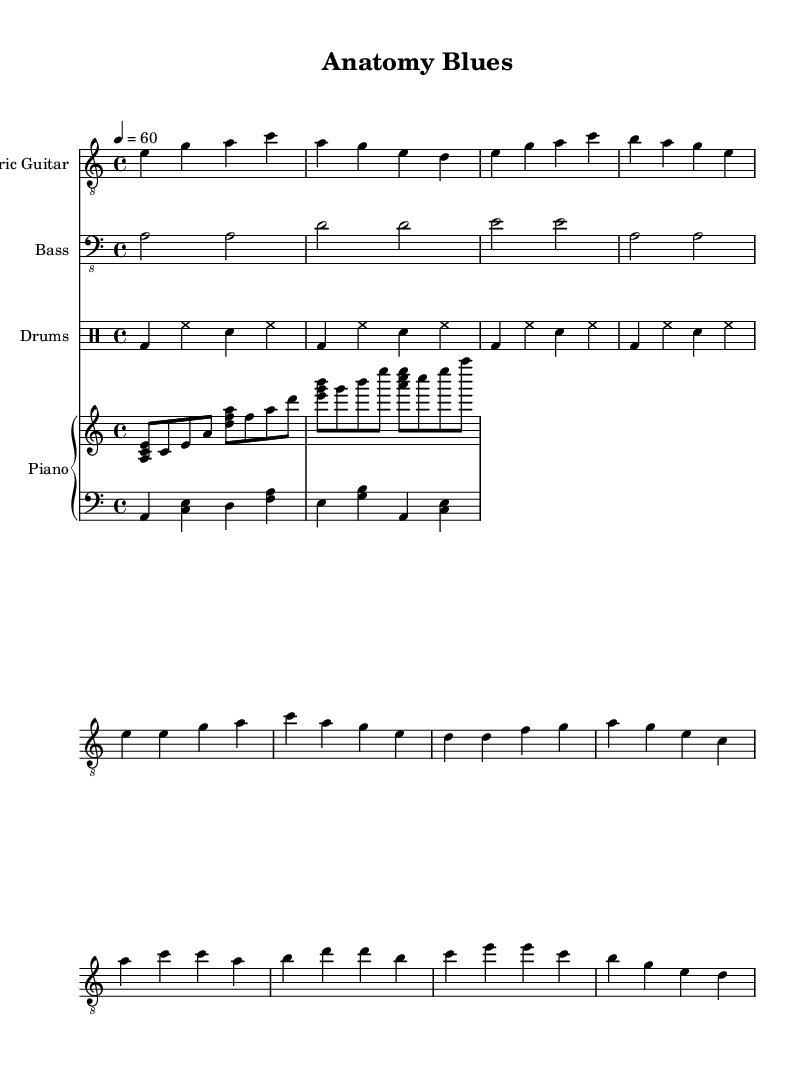What is the key signature of this music? The key signature shows an A minor key, indicated by zero sharps and flats in the context of the relative major, C major.
Answer: A minor What is the time signature of this music? The time signature is written at the beginning of the score as 4/4, meaning there are four beats per measure, and the quarter note gets one beat.
Answer: 4/4 What is the tempo marking of this music? The tempo marking is indicated as a quarter note equals 60 beats per minute, suggesting a slow to moderate pace for the piece.
Answer: 60 How many measures are there in the electric guitar part? Counting the segments separated by bar lines in the electric guitar staff shows there are a total of 12 measures.
Answer: 12 What kind of rhythm is predominantly used in the drum part? The drum part features a standard blues rhythm, mainly characterized by alternating bass drum and snare hits with hi-hat patterns.
Answer: Blues rhythm What instrument plays the arpeggiated chords in this composition? The arpeggiated chords in this piece are played by the right hand of the piano, as indicated by the notation within the piano staff.
Answer: Piano Which section of the composition is labeled as the chorus? The chorus is identifiable by the change in musical lines to a different melodic sequence after the initial verse, specifically the measures starting after the second verse.
Answer: Measures from the electric guitar part indicating the chorus 